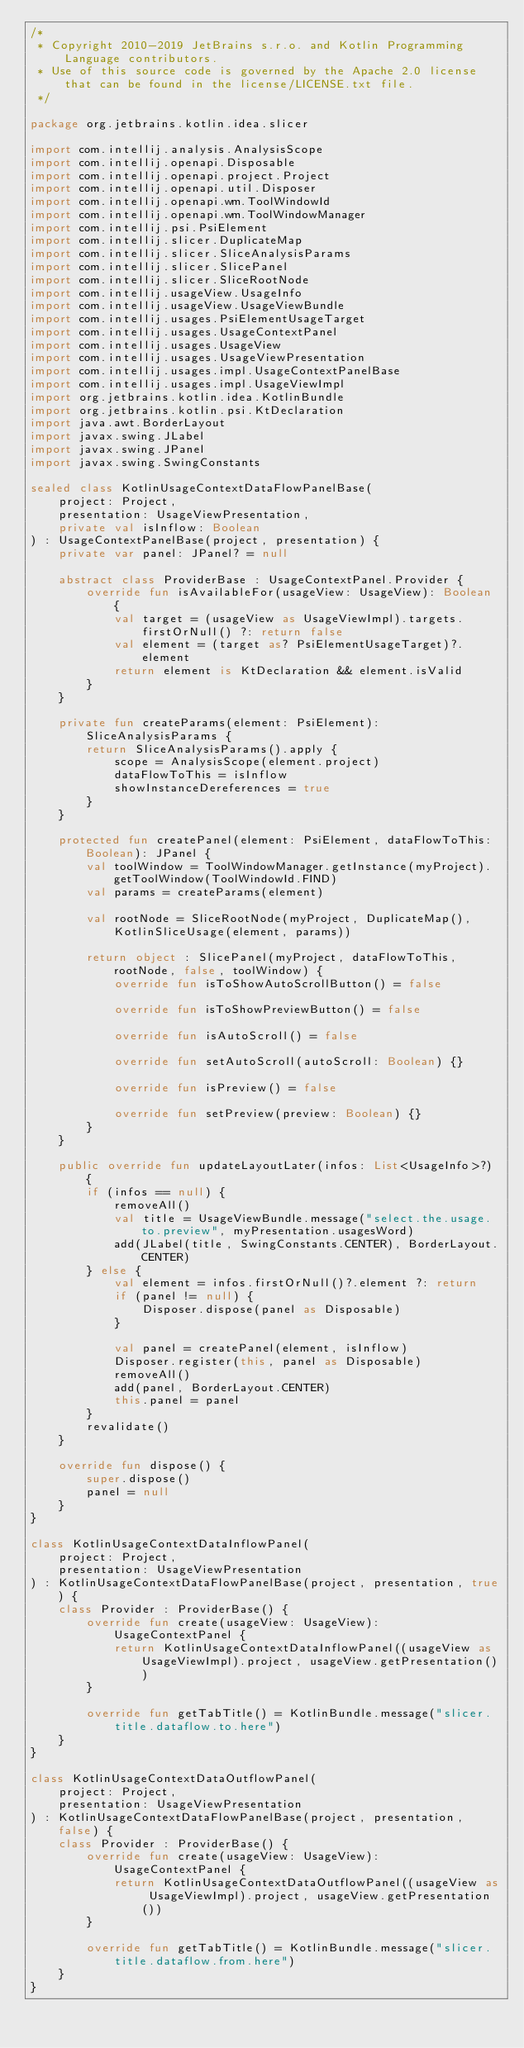Convert code to text. <code><loc_0><loc_0><loc_500><loc_500><_Kotlin_>/*
 * Copyright 2010-2019 JetBrains s.r.o. and Kotlin Programming Language contributors.
 * Use of this source code is governed by the Apache 2.0 license that can be found in the license/LICENSE.txt file.
 */

package org.jetbrains.kotlin.idea.slicer

import com.intellij.analysis.AnalysisScope
import com.intellij.openapi.Disposable
import com.intellij.openapi.project.Project
import com.intellij.openapi.util.Disposer
import com.intellij.openapi.wm.ToolWindowId
import com.intellij.openapi.wm.ToolWindowManager
import com.intellij.psi.PsiElement
import com.intellij.slicer.DuplicateMap
import com.intellij.slicer.SliceAnalysisParams
import com.intellij.slicer.SlicePanel
import com.intellij.slicer.SliceRootNode
import com.intellij.usageView.UsageInfo
import com.intellij.usageView.UsageViewBundle
import com.intellij.usages.PsiElementUsageTarget
import com.intellij.usages.UsageContextPanel
import com.intellij.usages.UsageView
import com.intellij.usages.UsageViewPresentation
import com.intellij.usages.impl.UsageContextPanelBase
import com.intellij.usages.impl.UsageViewImpl
import org.jetbrains.kotlin.idea.KotlinBundle
import org.jetbrains.kotlin.psi.KtDeclaration
import java.awt.BorderLayout
import javax.swing.JLabel
import javax.swing.JPanel
import javax.swing.SwingConstants

sealed class KotlinUsageContextDataFlowPanelBase(
    project: Project,
    presentation: UsageViewPresentation,
    private val isInflow: Boolean
) : UsageContextPanelBase(project, presentation) {
    private var panel: JPanel? = null

    abstract class ProviderBase : UsageContextPanel.Provider {
        override fun isAvailableFor(usageView: UsageView): Boolean {
            val target = (usageView as UsageViewImpl).targets.firstOrNull() ?: return false
            val element = (target as? PsiElementUsageTarget)?.element
            return element is KtDeclaration && element.isValid
        }
    }

    private fun createParams(element: PsiElement): SliceAnalysisParams {
        return SliceAnalysisParams().apply {
            scope = AnalysisScope(element.project)
            dataFlowToThis = isInflow
            showInstanceDereferences = true
        }
    }

    protected fun createPanel(element: PsiElement, dataFlowToThis: Boolean): JPanel {
        val toolWindow = ToolWindowManager.getInstance(myProject).getToolWindow(ToolWindowId.FIND)
        val params = createParams(element)

        val rootNode = SliceRootNode(myProject, DuplicateMap(), KotlinSliceUsage(element, params))

        return object : SlicePanel(myProject, dataFlowToThis, rootNode, false, toolWindow) {
            override fun isToShowAutoScrollButton() = false

            override fun isToShowPreviewButton() = false

            override fun isAutoScroll() = false

            override fun setAutoScroll(autoScroll: Boolean) {}

            override fun isPreview() = false

            override fun setPreview(preview: Boolean) {}
        }
    }

    public override fun updateLayoutLater(infos: List<UsageInfo>?) {
        if (infos == null) {
            removeAll()
            val title = UsageViewBundle.message("select.the.usage.to.preview", myPresentation.usagesWord)
            add(JLabel(title, SwingConstants.CENTER), BorderLayout.CENTER)
        } else {
            val element = infos.firstOrNull()?.element ?: return
            if (panel != null) {
                Disposer.dispose(panel as Disposable)
            }

            val panel = createPanel(element, isInflow)
            Disposer.register(this, panel as Disposable)
            removeAll()
            add(panel, BorderLayout.CENTER)
            this.panel = panel
        }
        revalidate()
    }

    override fun dispose() {
        super.dispose()
        panel = null
    }
}

class KotlinUsageContextDataInflowPanel(
    project: Project,
    presentation: UsageViewPresentation
) : KotlinUsageContextDataFlowPanelBase(project, presentation, true) {
    class Provider : ProviderBase() {
        override fun create(usageView: UsageView): UsageContextPanel {
            return KotlinUsageContextDataInflowPanel((usageView as UsageViewImpl).project, usageView.getPresentation())
        }

        override fun getTabTitle() = KotlinBundle.message("slicer.title.dataflow.to.here")
    }
}

class KotlinUsageContextDataOutflowPanel(
    project: Project,
    presentation: UsageViewPresentation
) : KotlinUsageContextDataFlowPanelBase(project, presentation, false) {
    class Provider : ProviderBase() {
        override fun create(usageView: UsageView): UsageContextPanel {
            return KotlinUsageContextDataOutflowPanel((usageView as UsageViewImpl).project, usageView.getPresentation())
        }

        override fun getTabTitle() = KotlinBundle.message("slicer.title.dataflow.from.here")
    }
}</code> 